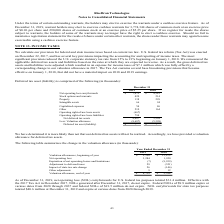From Ricebran Technologies's financial document, What are the respective net operating loss carryforwards in 2018 and 2019? The document shows two values: $4,541 and $7,672 (in thousands). From the document: "Net operating loss carryforwards 7,672 $ 4,541 $ Net operating loss carryforwards 7,672 $ 4,541 $..." Also, What are the respective values of stock options and warrants in 2018 and 2019? The document shows two values: 214 and 420 (in thousands). From the document: "Stock options and warrants 420 214 Stock options and warrants 420 214..." Also, What are the respective property values in 2018 and 2019? The document shows two values: 299 and 138 (in thousands). From the document: "Property 138 299 Property 138 299..." Also, can you calculate: What is the average net operating loss carryforward in 2018 and 2019? To answer this question, I need to perform calculations using the financial data. The calculation is: (7,672 + 4,541)/2 , which equals 6106.5 (in thousands). This is based on the information: "Net operating loss carryforwards 7,672 $ 4,541 $ Net operating loss carryforwards 7,672 $ 4,541 $..." The key data points involved are: 4,541, 7,672. Also, can you calculate: What is the percentage change in net operating loss carryforward in 2018 and 2019? To answer this question, I need to perform calculations using the financial data. The calculation is: (7,672 - 4,541)/4,541 , which equals 68.95 (percentage). This is based on the information: "Net operating loss carryforwards 7,672 $ 4,541 $ Net operating loss carryforwards 7,672 $ 4,541 $..." The key data points involved are: 4,541, 7,672. Also, can you calculate: What is the percentage change in the stock options and warrants between 2018 and 2019? To answer this question, I need to perform calculations using the financial data. The calculation is: (420 - 214)/214 , which equals 96.26 (percentage). This is based on the information: "Stock options and warrants 420 214 Stock options and warrants 420 214..." The key data points involved are: 214, 420. 